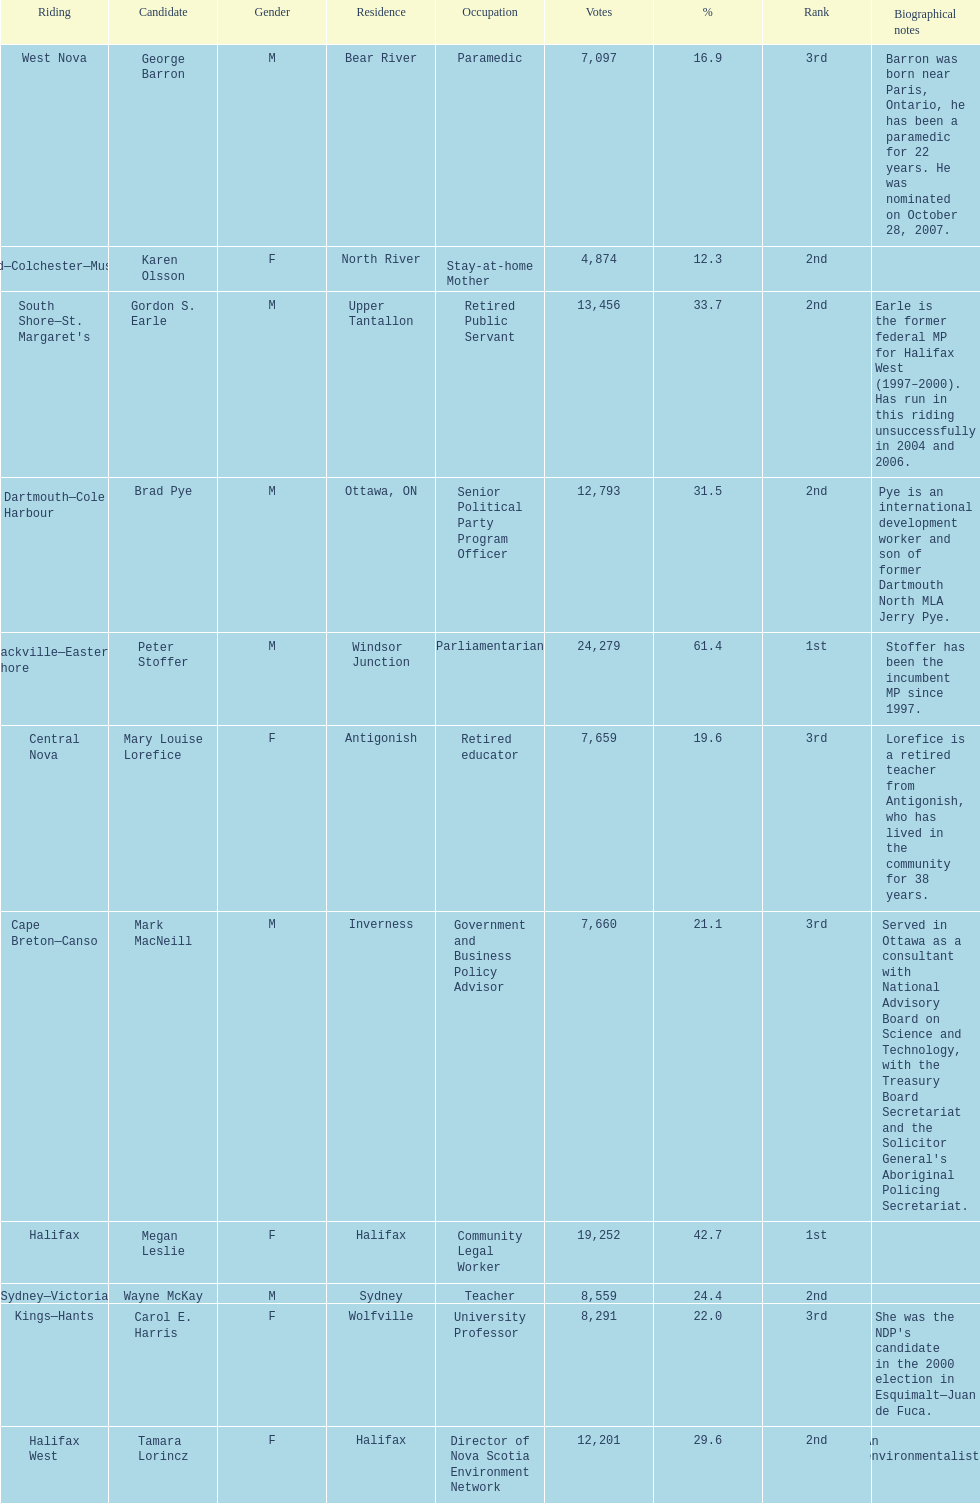How many of the candidates were females? 5. 